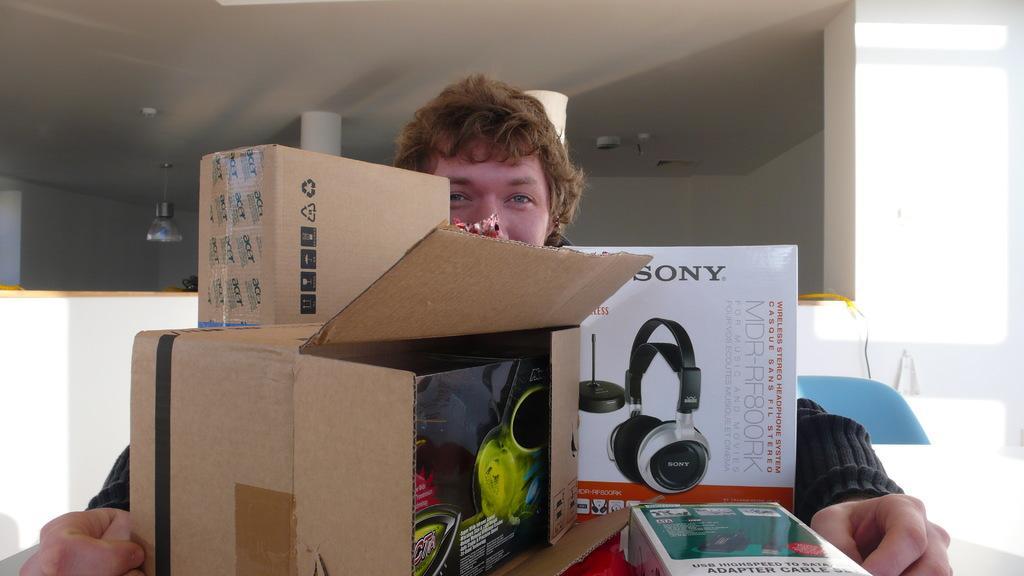Could you give a brief overview of what you see in this image? This image consists of a man. In front of him, we can see the boxes made up of cardboard. In which there are gadgets. In the background, we can see a wall and a roof along with the pillars. On the right, there is a chair. 